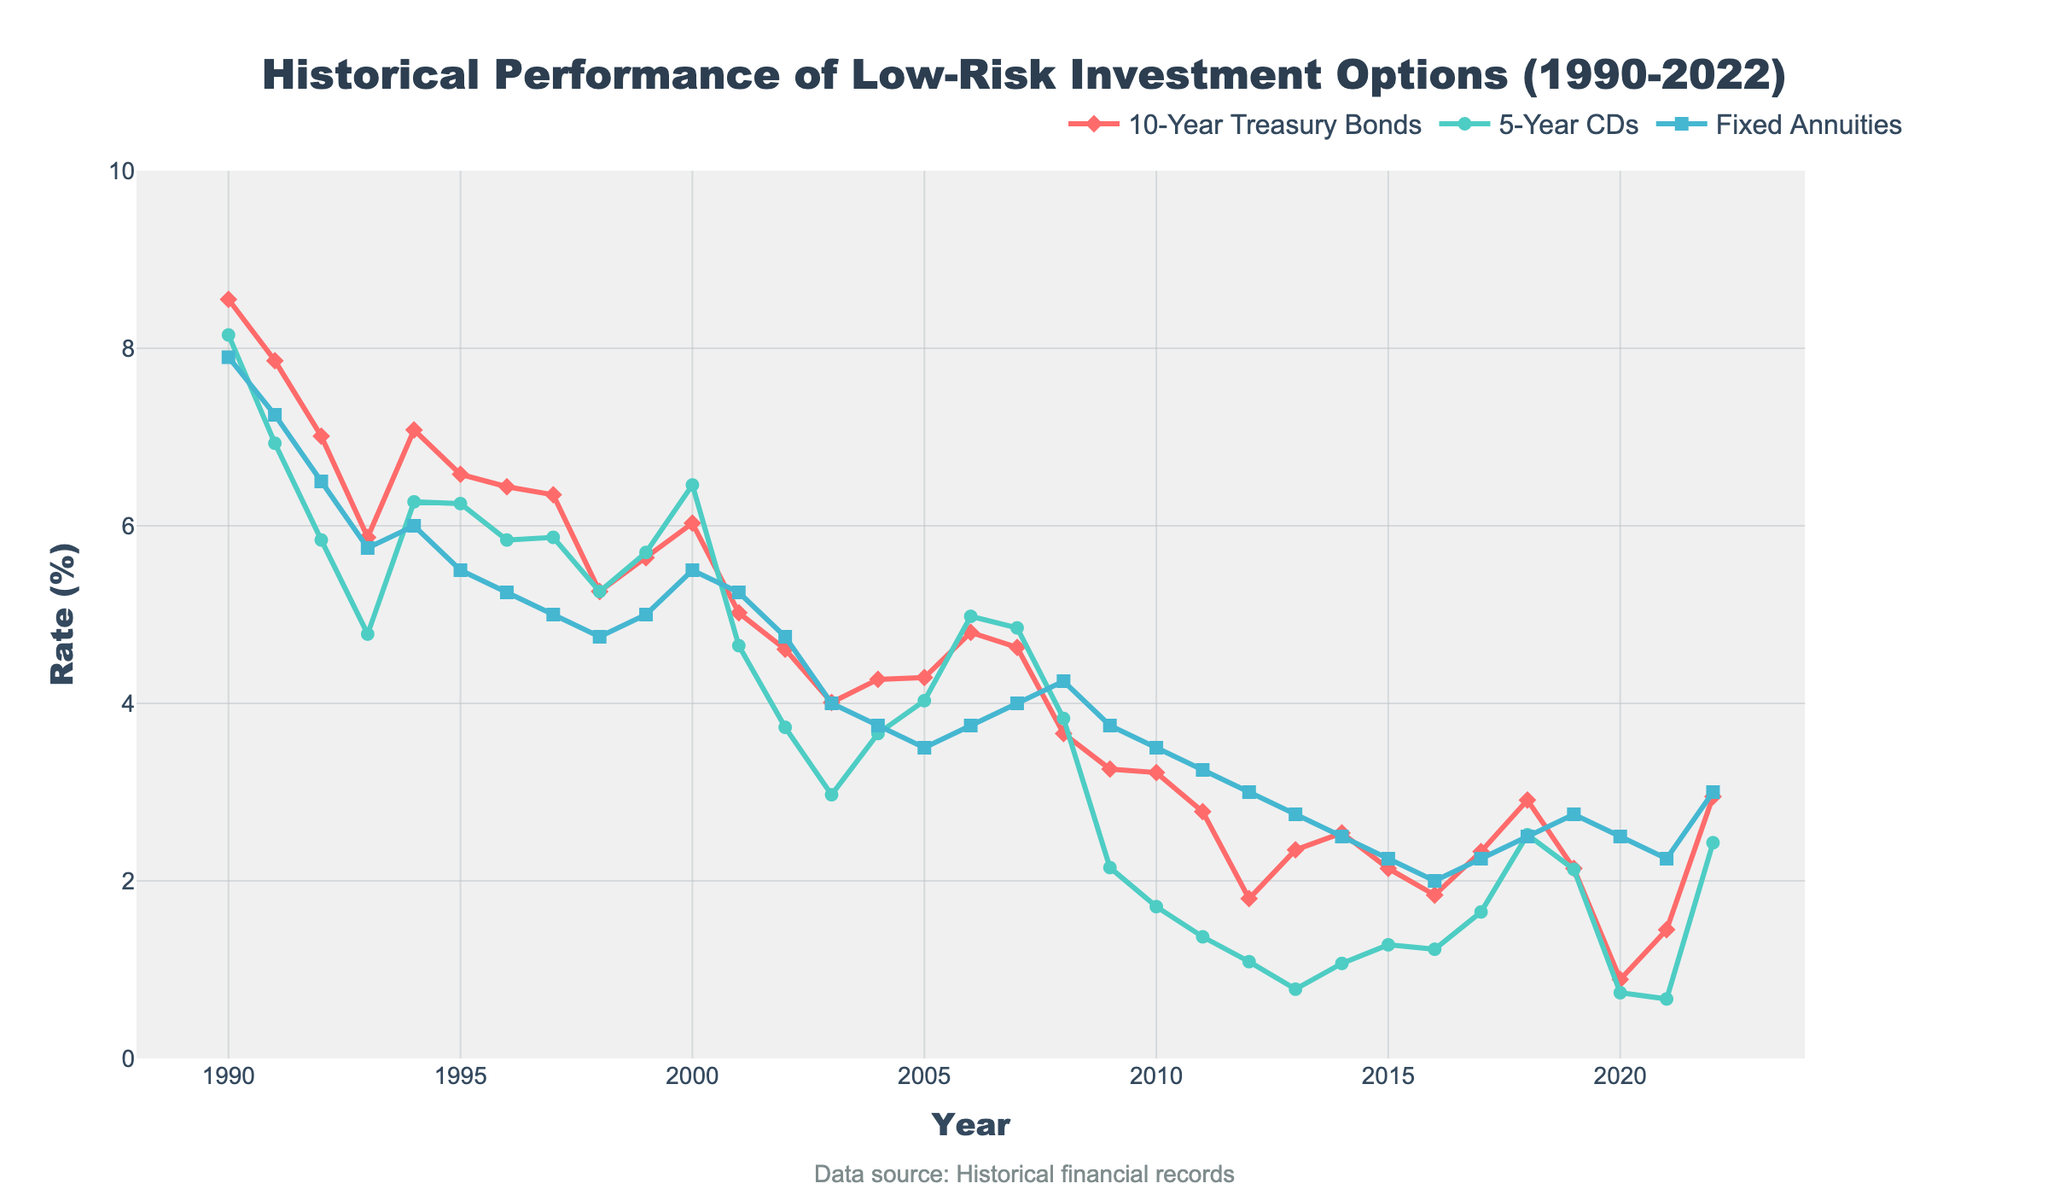What was the rate for 10-Year Treasury Bonds in 2000? To find this, look at the point corresponding to the year 2000 on the line for 10-Year Treasury Bonds (red line).
Answer: 6.03% How did the rates of 10-Year Treasury Bonds and 5-Year CDs compare in 1994? Locate the points for 1994 on both the 10-Year Treasury Bonds (red line) and the 5-Year CDs (green line). Compare these values.
Answer: 10-Year Treasury Bonds were higher at 7.08% vs. 6.27% What is the average rate of Fixed Annuities from 1990 to 2000? Look at the Fixed Annuities values (blue line) from 1990 to 2000 and sum them: (7.90 + 7.25 + 6.50 + 5.75 + 6.00 + 5.50 + 5.25 + 5.00 + 4.75 + 5.00 + 5.50). Then divide by the number of years (11).
Answer: 5.83% Between which years did 10-Year Treasury Bonds see the most significant drop? Examine the red line and find the steepest decline year to year.
Answer: 1994 to 1995 Which year had the lowest rate for 5-Year CDs? Find the lowest point on the green line and note the corresponding year.
Answer: 2013 Did the rate of Fixed Annuities ever surpass the rate of 10-Year Treasury Bonds? Look across both the blue and red lines to see if the blue line ever goes above the red line.
Answer: No Which investment option had the highest rate in 1990? Compare the values for 1990 across the three lines: 10-Year Treasury Bonds, 5-Year CDs, and Fixed Annuities.
Answer: 10-Year Treasury Bonds Calculate the difference between the highest and lowest rates of Fixed Annuities over the entire period. Identify the maximum (7.90% in 1990) and minimum (2.00% in 2016) rates of Fixed Annuities and subtract the lowest from the highest.
Answer: 5.90% In which year did the rate of 10-Year Treasury Bonds fall below 3% for the first time? Trace the red line and look for the first year where it dips below 3%.
Answer: 2011 By how much did the rate for 5-Year CDs increase from 2020 to 2022? Subtract the value for 2020 from the value in 2022 using the green line: 2.43% - 0.74%.
Answer: 1.69% 